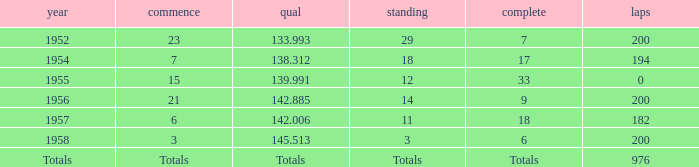What place did Jimmy Reece start from when he ranked 12? 15.0. 